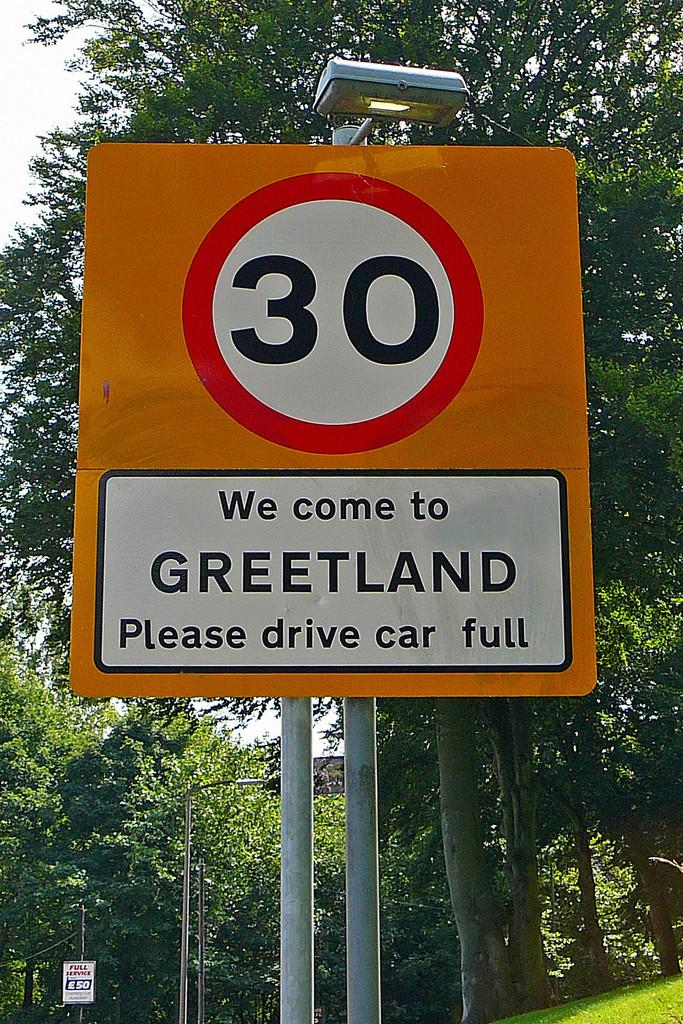<image>
Relay a brief, clear account of the picture shown. A road sign saying We Come To Greetland Please drive car full. 